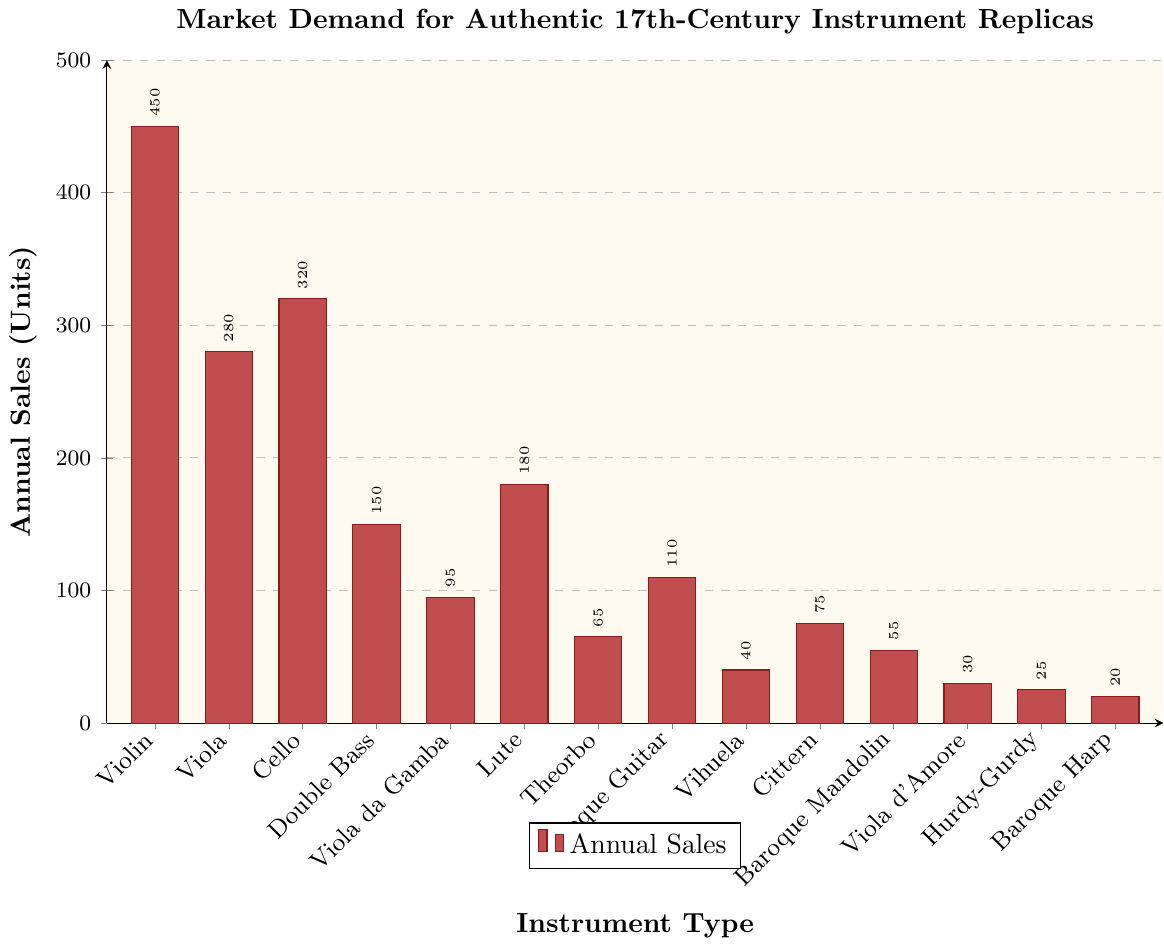What instrument has the highest annual sales? The violin has the highest bar in the chart, indicating it has the highest annual sales.
Answer: Violin Which instrument has the lowest annual sales? The bar for the Baroque Harp is the shortest, showing it has the lowest annual sales.
Answer: Baroque Harp What is the combined annual sales of the Violin and Cello? The annual sales of the Violin is 450 units, and the Cello is 320 units. Adding these together gives 450 + 320 = 770 units.
Answer: 770 units How much higher are the annual sales of the Violin compared to the Double Bass? The Violin has 450 units, and the Double Bass has 150 units. The difference is 450 - 150 = 300 units.
Answer: 300 units Between the Viola da Gamba and the Baroque Guitar, which has more annual sales, and by how much? The Baroque Guitar has 110 annual sales, and the Viola da Gamba has 95. The difference is 110 - 95 = 15 units.
Answer: Baroque Guitar, by 15 units Which instrument types have sales greater than 100 units per year? Examining the bars, the instrument types Violin, Viola, Cello, Double Bass, Lute, and Baroque Guitar all have bars exceeding the 100-unit mark.
Answer: Violin, Viola, Cello, Double Bass, Lute, Baroque Guitar If the annual sales of the Lute were to double, what would they be? The current annual sales of the Lute are 180 units. Doubling this value gives 180 * 2 = 360 units.
Answer: 360 units How does the height of the Violin's bar compare to that of the Viola da Gamba? The Violin's bar is taller and reaches 450 units, whereas the Viola da Gamba's bar is shorter and reaches 95 units.
Answer: The Violin's bar is taller What is the average annual sales across all instrument types? To find the average, sum all the annual sales and divide by the number of instruments. The sum is 450 + 280 + 320 + 150 + 95 + 180 + 65 + 110 + 40 + 75 + 55 + 30 + 25 + 20 = 1895 units. There are 14 instruments, so the average is 1895 / 14 ≈ 135.36 units.
Answer: 135.36 units 